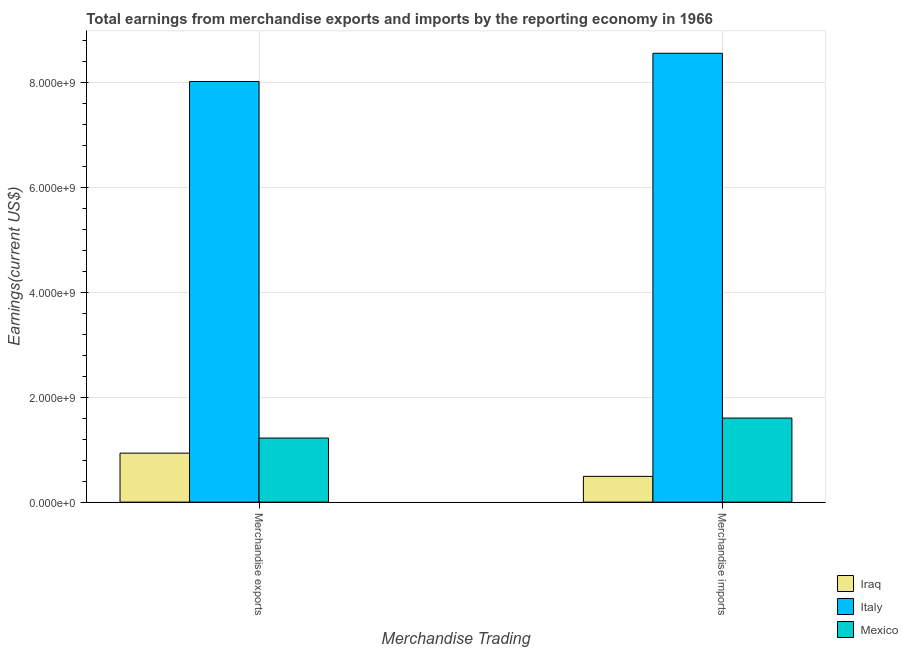How many different coloured bars are there?
Make the answer very short. 3. How many groups of bars are there?
Your response must be concise. 2. How many bars are there on the 2nd tick from the right?
Provide a succinct answer. 3. What is the label of the 2nd group of bars from the left?
Provide a short and direct response. Merchandise imports. What is the earnings from merchandise exports in Italy?
Make the answer very short. 8.03e+09. Across all countries, what is the maximum earnings from merchandise exports?
Offer a very short reply. 8.03e+09. Across all countries, what is the minimum earnings from merchandise imports?
Give a very brief answer. 4.92e+08. In which country was the earnings from merchandise exports minimum?
Offer a very short reply. Iraq. What is the total earnings from merchandise imports in the graph?
Give a very brief answer. 1.07e+1. What is the difference between the earnings from merchandise exports in Italy and that in Mexico?
Provide a succinct answer. 6.80e+09. What is the difference between the earnings from merchandise imports in Mexico and the earnings from merchandise exports in Italy?
Offer a terse response. -6.42e+09. What is the average earnings from merchandise exports per country?
Your response must be concise. 3.39e+09. What is the difference between the earnings from merchandise imports and earnings from merchandise exports in Iraq?
Your answer should be compact. -4.43e+08. In how many countries, is the earnings from merchandise exports greater than 8000000000 US$?
Provide a succinct answer. 1. What is the ratio of the earnings from merchandise exports in Iraq to that in Italy?
Offer a very short reply. 0.12. What does the 1st bar from the left in Merchandise exports represents?
Offer a very short reply. Iraq. What does the 3rd bar from the right in Merchandise exports represents?
Give a very brief answer. Iraq. What is the difference between two consecutive major ticks on the Y-axis?
Your answer should be very brief. 2.00e+09. Does the graph contain any zero values?
Give a very brief answer. No. Does the graph contain grids?
Give a very brief answer. Yes. How many legend labels are there?
Keep it short and to the point. 3. What is the title of the graph?
Your response must be concise. Total earnings from merchandise exports and imports by the reporting economy in 1966. What is the label or title of the X-axis?
Provide a succinct answer. Merchandise Trading. What is the label or title of the Y-axis?
Give a very brief answer. Earnings(current US$). What is the Earnings(current US$) in Iraq in Merchandise exports?
Your response must be concise. 9.35e+08. What is the Earnings(current US$) of Italy in Merchandise exports?
Offer a terse response. 8.03e+09. What is the Earnings(current US$) of Mexico in Merchandise exports?
Ensure brevity in your answer.  1.22e+09. What is the Earnings(current US$) of Iraq in Merchandise imports?
Your response must be concise. 4.92e+08. What is the Earnings(current US$) of Italy in Merchandise imports?
Offer a very short reply. 8.56e+09. What is the Earnings(current US$) of Mexico in Merchandise imports?
Your response must be concise. 1.60e+09. Across all Merchandise Trading, what is the maximum Earnings(current US$) of Iraq?
Give a very brief answer. 9.35e+08. Across all Merchandise Trading, what is the maximum Earnings(current US$) of Italy?
Provide a short and direct response. 8.56e+09. Across all Merchandise Trading, what is the maximum Earnings(current US$) of Mexico?
Offer a very short reply. 1.60e+09. Across all Merchandise Trading, what is the minimum Earnings(current US$) of Iraq?
Your response must be concise. 4.92e+08. Across all Merchandise Trading, what is the minimum Earnings(current US$) of Italy?
Give a very brief answer. 8.03e+09. Across all Merchandise Trading, what is the minimum Earnings(current US$) in Mexico?
Give a very brief answer. 1.22e+09. What is the total Earnings(current US$) of Iraq in the graph?
Your answer should be compact. 1.43e+09. What is the total Earnings(current US$) of Italy in the graph?
Offer a terse response. 1.66e+1. What is the total Earnings(current US$) in Mexico in the graph?
Offer a very short reply. 2.83e+09. What is the difference between the Earnings(current US$) of Iraq in Merchandise exports and that in Merchandise imports?
Offer a very short reply. 4.43e+08. What is the difference between the Earnings(current US$) in Italy in Merchandise exports and that in Merchandise imports?
Your answer should be compact. -5.38e+08. What is the difference between the Earnings(current US$) of Mexico in Merchandise exports and that in Merchandise imports?
Provide a succinct answer. -3.81e+08. What is the difference between the Earnings(current US$) of Iraq in Merchandise exports and the Earnings(current US$) of Italy in Merchandise imports?
Your answer should be compact. -7.63e+09. What is the difference between the Earnings(current US$) of Iraq in Merchandise exports and the Earnings(current US$) of Mexico in Merchandise imports?
Offer a terse response. -6.69e+08. What is the difference between the Earnings(current US$) in Italy in Merchandise exports and the Earnings(current US$) in Mexico in Merchandise imports?
Provide a short and direct response. 6.42e+09. What is the average Earnings(current US$) in Iraq per Merchandise Trading?
Offer a terse response. 7.13e+08. What is the average Earnings(current US$) in Italy per Merchandise Trading?
Provide a succinct answer. 8.30e+09. What is the average Earnings(current US$) of Mexico per Merchandise Trading?
Make the answer very short. 1.41e+09. What is the difference between the Earnings(current US$) in Iraq and Earnings(current US$) in Italy in Merchandise exports?
Ensure brevity in your answer.  -7.09e+09. What is the difference between the Earnings(current US$) of Iraq and Earnings(current US$) of Mexico in Merchandise exports?
Ensure brevity in your answer.  -2.88e+08. What is the difference between the Earnings(current US$) in Italy and Earnings(current US$) in Mexico in Merchandise exports?
Your answer should be very brief. 6.80e+09. What is the difference between the Earnings(current US$) of Iraq and Earnings(current US$) of Italy in Merchandise imports?
Ensure brevity in your answer.  -8.07e+09. What is the difference between the Earnings(current US$) in Iraq and Earnings(current US$) in Mexico in Merchandise imports?
Offer a very short reply. -1.11e+09. What is the difference between the Earnings(current US$) in Italy and Earnings(current US$) in Mexico in Merchandise imports?
Offer a terse response. 6.96e+09. What is the ratio of the Earnings(current US$) of Iraq in Merchandise exports to that in Merchandise imports?
Your response must be concise. 1.9. What is the ratio of the Earnings(current US$) in Italy in Merchandise exports to that in Merchandise imports?
Your answer should be compact. 0.94. What is the ratio of the Earnings(current US$) in Mexico in Merchandise exports to that in Merchandise imports?
Give a very brief answer. 0.76. What is the difference between the highest and the second highest Earnings(current US$) in Iraq?
Provide a short and direct response. 4.43e+08. What is the difference between the highest and the second highest Earnings(current US$) of Italy?
Your answer should be compact. 5.38e+08. What is the difference between the highest and the second highest Earnings(current US$) in Mexico?
Provide a short and direct response. 3.81e+08. What is the difference between the highest and the lowest Earnings(current US$) of Iraq?
Ensure brevity in your answer.  4.43e+08. What is the difference between the highest and the lowest Earnings(current US$) of Italy?
Offer a terse response. 5.38e+08. What is the difference between the highest and the lowest Earnings(current US$) of Mexico?
Keep it short and to the point. 3.81e+08. 